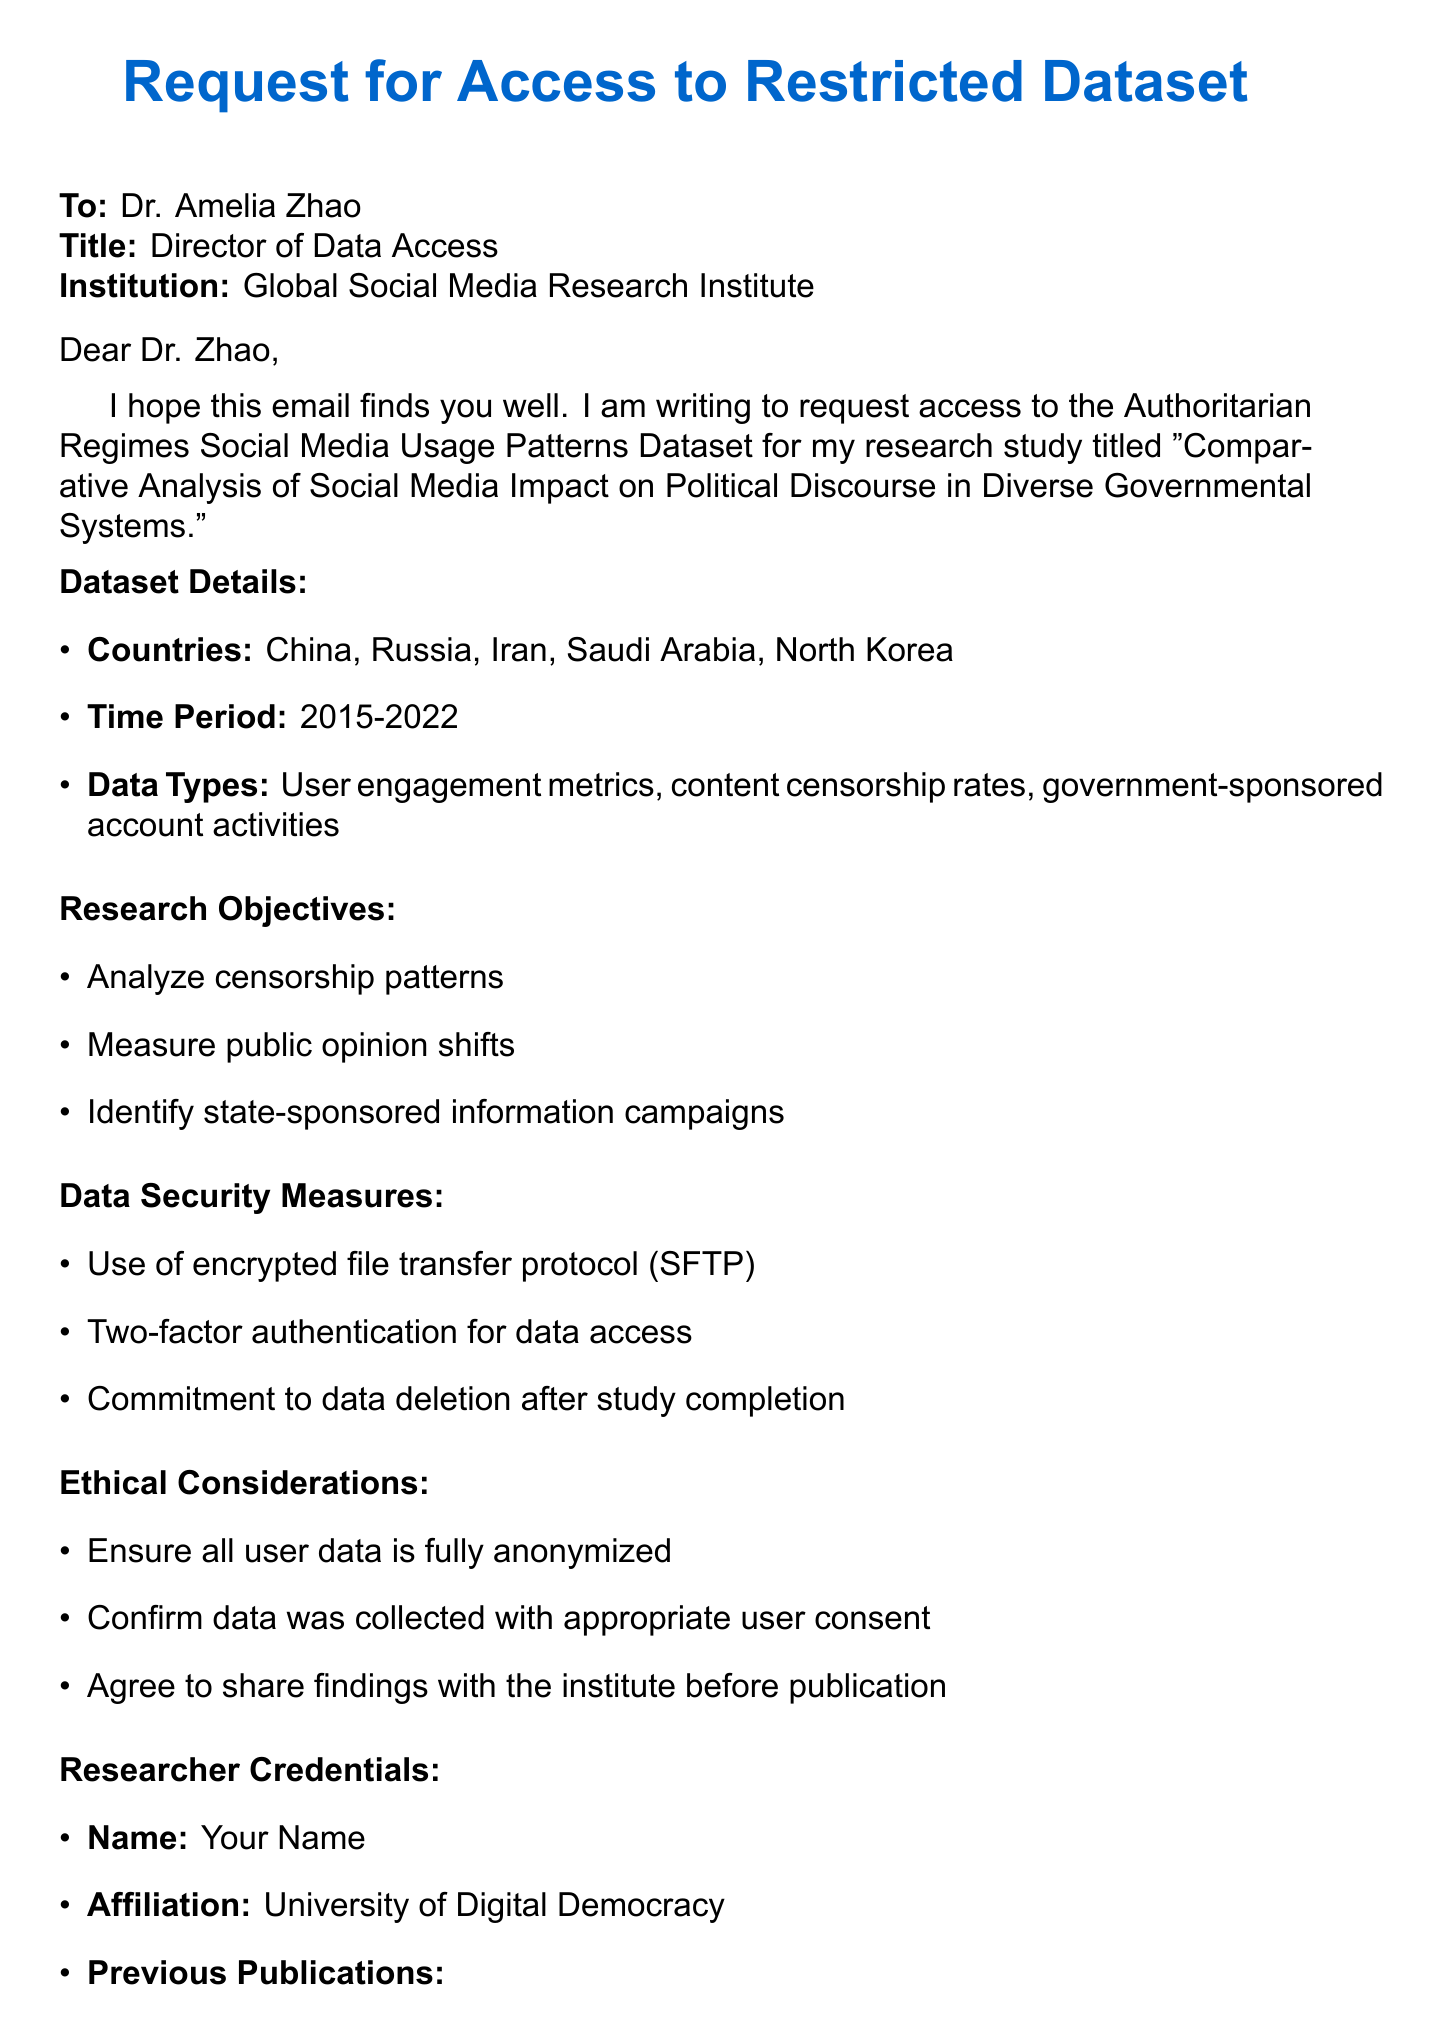What is the title of the research study? The title of the research study is mentioned as "Comparative Analysis of Social Media Impact on Political Discourse in Diverse Governmental Systems."
Answer: Comparative Analysis of Social Media Impact on Political Discourse in Diverse Governmental Systems Who is the recipient of the email? The email is addressed to Dr. Amelia Zhao, identified as the Director of Data Access.
Answer: Dr. Amelia Zhao What are the countries included in the dataset? The document specifies five countries for the dataset: China, Russia, Iran, Saudi Arabia, North Korea.
Answer: China, Russia, Iran, Saudi Arabia, North Korea What is the expected completion date of the study? The document states that the expected study completion date is March 31, 2024.
Answer: March 31, 2024 Which data security measure involves user verification? The document mentions two-factor authentication as a measure for user verification.
Answer: Two-factor authentication What is one of the key objectives of the research? The document lists several key objectives, one of which is to analyze censorship patterns.
Answer: Analyze censorship patterns What is the time period covered by the dataset? The time period specified for the dataset is from 2015 to 2022.
Answer: 2015-2022 What commitment is made regarding data after the study completion? The document states there is a commitment to data deletion after the study is completed.
Answer: Commitment to data deletion after study completion 